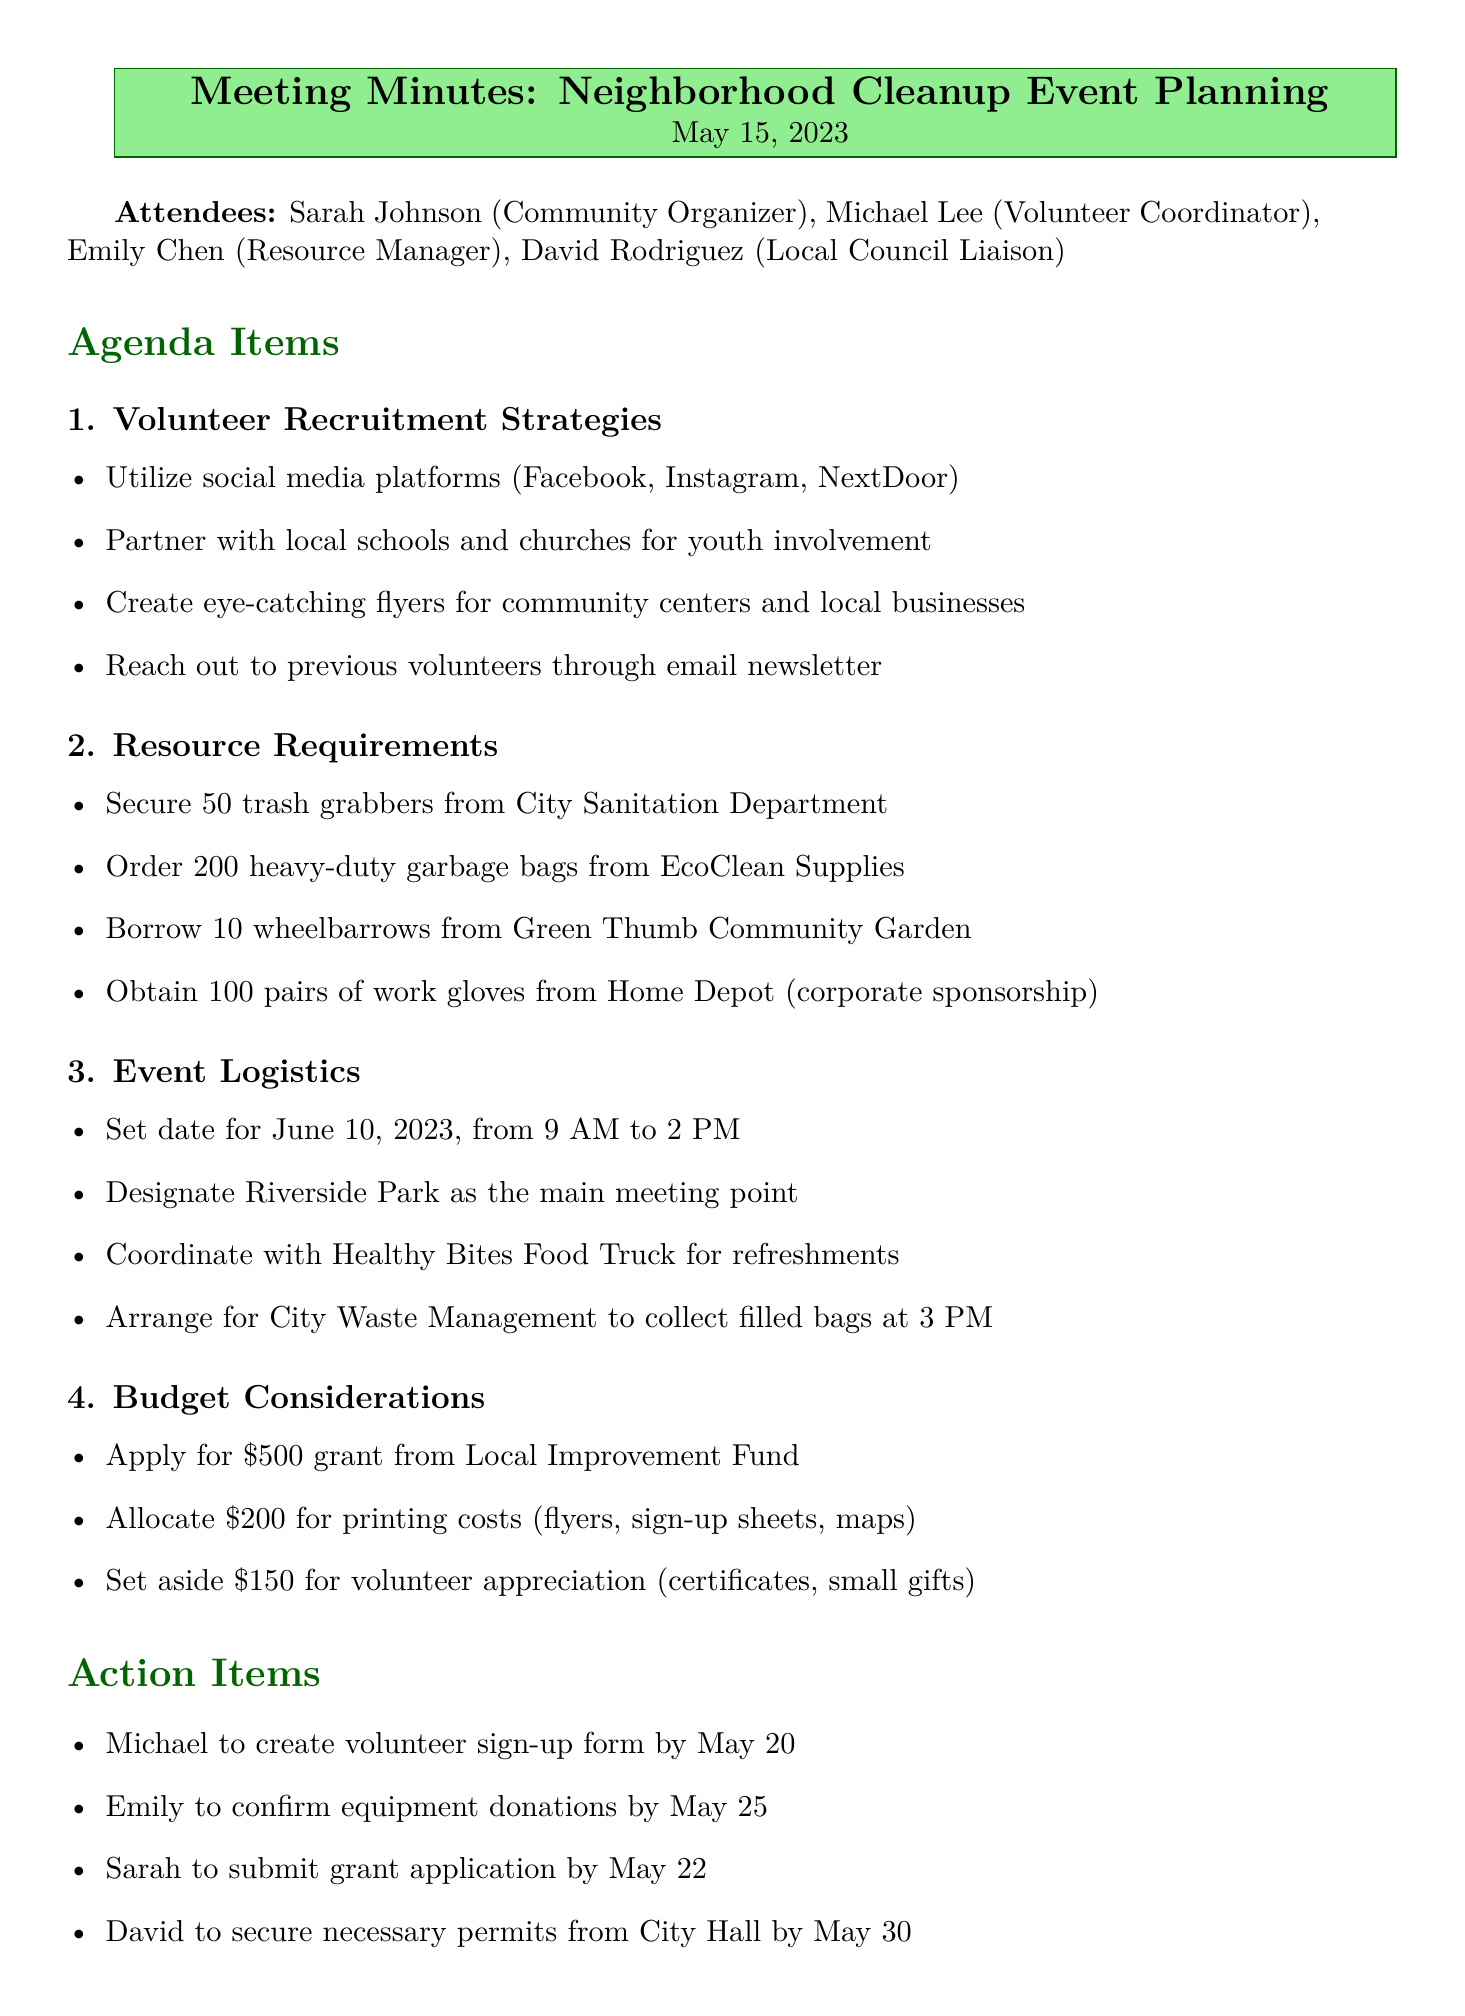What is the date of the cleanup event? The date of the cleanup event is specified in the agenda under Event Logistics.
Answer: June 10, 2023 Who is responsible for creating the volunteer sign-up form? The action item specifies who is responsible for each task, which includes creating the sign-up form.
Answer: Michael How many heavy-duty garbage bags need to be ordered? The Resource Requirements section lists the number of garbage bags needed.
Answer: 200 Which park is designated as the main meeting point for the event? The meeting point is outlined in the Event Logistics section of the document.
Answer: Riverside Park What is the total allocated budget for printing costs? The budget section details the amount allocated specifically for printing costs.
Answer: 200 How many trash grabbers are to be secured from the City Sanitation Department? The Resource Requirements section indicates the number of trash grabbers needed.
Answer: 50 What is the deadline for Emily to confirm equipment donations? The action items section provides the specific deadline for confirming equipment donations.
Answer: May 25 What type of food truck is coordinated for volunteer refreshments? The Event Logistics section mentions the type of food truck for refreshments.
Answer: Healthy Bites Food Truck 